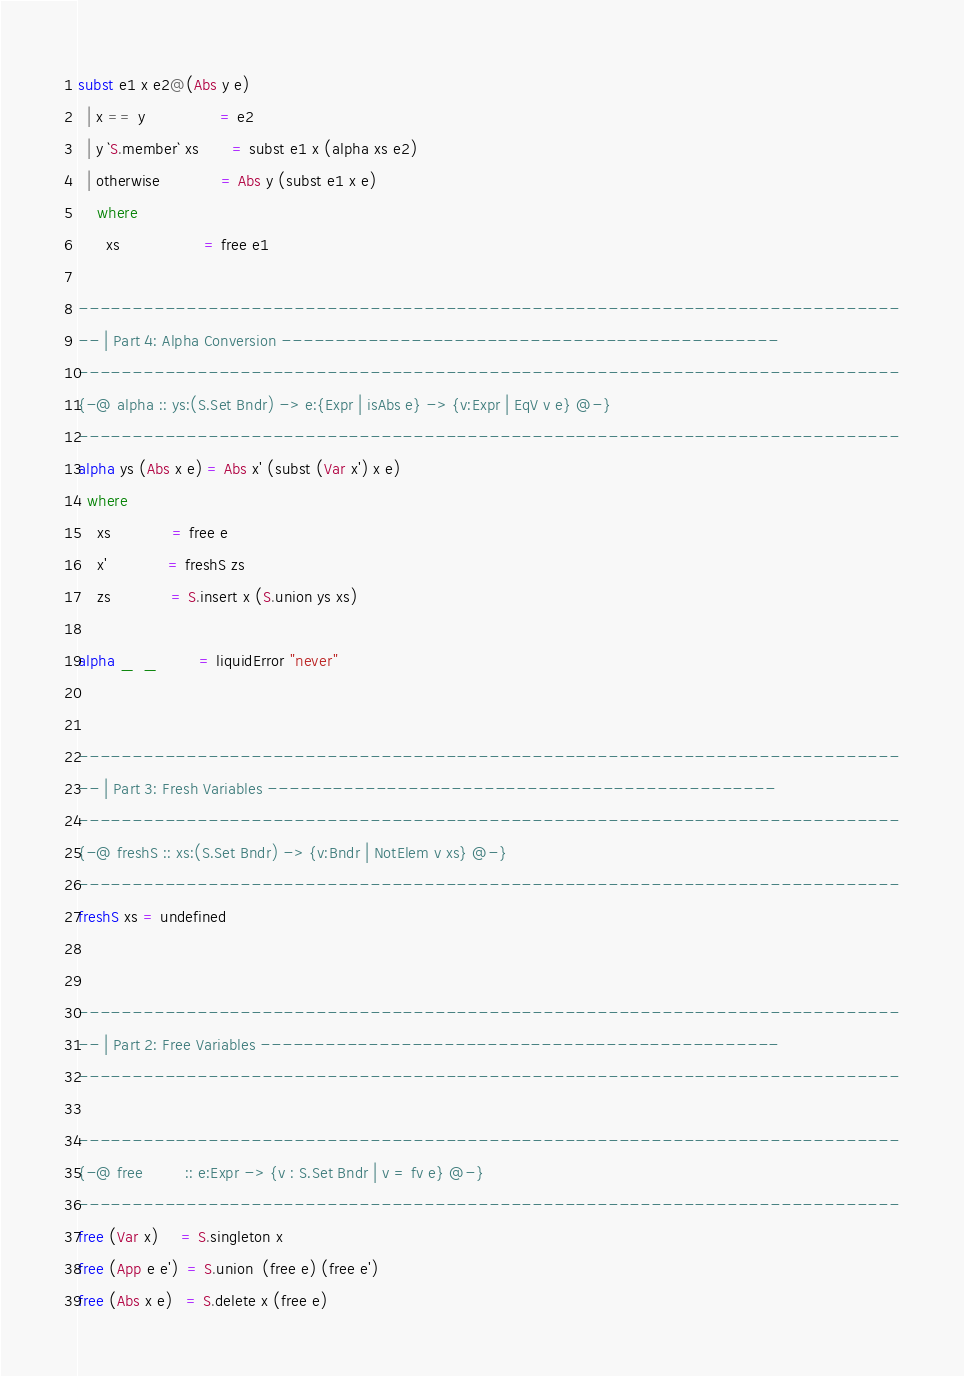<code> <loc_0><loc_0><loc_500><loc_500><_Haskell_>
subst e1 x e2@(Abs y e)
  | x == y                = e2
  | y `S.member` xs       = subst e1 x (alpha xs e2)
  | otherwise             = Abs y (subst e1 x e)
    where
      xs                  = free e1

----------------------------------------------------------------------------
-- | Part 4: Alpha Conversion ----------------------------------------------
----------------------------------------------------------------------------
{-@ alpha :: ys:(S.Set Bndr) -> e:{Expr | isAbs e} -> {v:Expr | EqV v e} @-}
----------------------------------------------------------------------------
alpha ys (Abs x e) = Abs x' (subst (Var x') x e)
  where
    xs             = free e
    x'             = freshS zs
    zs             = S.insert x (S.union ys xs)

alpha _  _         = liquidError "never"


----------------------------------------------------------------------------
-- | Part 3: Fresh Variables -----------------------------------------------
----------------------------------------------------------------------------
{-@ freshS :: xs:(S.Set Bndr) -> {v:Bndr | NotElem v xs} @-}
----------------------------------------------------------------------------
freshS xs = undefined


----------------------------------------------------------------------------
-- | Part 2: Free Variables ------------------------------------------------
----------------------------------------------------------------------------

----------------------------------------------------------------------------
{-@ free         :: e:Expr -> {v : S.Set Bndr | v = fv e} @-}
----------------------------------------------------------------------------
free (Var x)     = S.singleton x
free (App e e')  = S.union  (free e) (free e')
free (Abs x e)   = S.delete x (free e)
</code> 